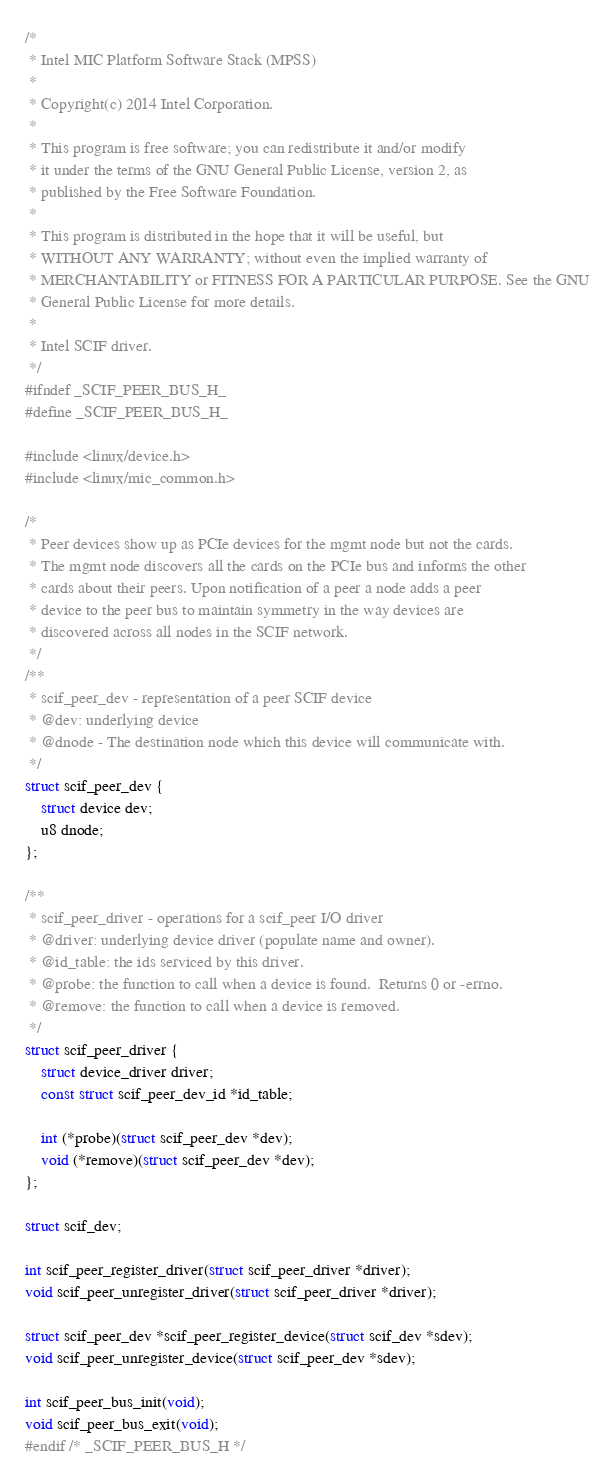Convert code to text. <code><loc_0><loc_0><loc_500><loc_500><_C_>/*
 * Intel MIC Platform Software Stack (MPSS)
 *
 * Copyright(c) 2014 Intel Corporation.
 *
 * This program is free software; you can redistribute it and/or modify
 * it under the terms of the GNU General Public License, version 2, as
 * published by the Free Software Foundation.
 *
 * This program is distributed in the hope that it will be useful, but
 * WITHOUT ANY WARRANTY; without even the implied warranty of
 * MERCHANTABILITY or FITNESS FOR A PARTICULAR PURPOSE. See the GNU
 * General Public License for more details.
 *
 * Intel SCIF driver.
 */
#ifndef _SCIF_PEER_BUS_H_
#define _SCIF_PEER_BUS_H_

#include <linux/device.h>
#include <linux/mic_common.h>

/*
 * Peer devices show up as PCIe devices for the mgmt node but not the cards.
 * The mgmt node discovers all the cards on the PCIe bus and informs the other
 * cards about their peers. Upon notification of a peer a node adds a peer
 * device to the peer bus to maintain symmetry in the way devices are
 * discovered across all nodes in the SCIF network.
 */
/**
 * scif_peer_dev - representation of a peer SCIF device
 * @dev: underlying device
 * @dnode - The destination node which this device will communicate with.
 */
struct scif_peer_dev {
	struct device dev;
	u8 dnode;
};

/**
 * scif_peer_driver - operations for a scif_peer I/O driver
 * @driver: underlying device driver (populate name and owner).
 * @id_table: the ids serviced by this driver.
 * @probe: the function to call when a device is found.  Returns 0 or -errno.
 * @remove: the function to call when a device is removed.
 */
struct scif_peer_driver {
	struct device_driver driver;
	const struct scif_peer_dev_id *id_table;

	int (*probe)(struct scif_peer_dev *dev);
	void (*remove)(struct scif_peer_dev *dev);
};

struct scif_dev;

int scif_peer_register_driver(struct scif_peer_driver *driver);
void scif_peer_unregister_driver(struct scif_peer_driver *driver);

struct scif_peer_dev *scif_peer_register_device(struct scif_dev *sdev);
void scif_peer_unregister_device(struct scif_peer_dev *sdev);

int scif_peer_bus_init(void);
void scif_peer_bus_exit(void);
#endif /* _SCIF_PEER_BUS_H */
</code> 